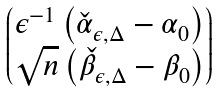<formula> <loc_0><loc_0><loc_500><loc_500>\begin{pmatrix} \epsilon ^ { - 1 } \left ( \check { \alpha } _ { \epsilon , \Delta } - \alpha _ { 0 } \right ) \\ \sqrt { n } \left ( \check { \beta } _ { \epsilon , \Delta } - \beta _ { 0 } \right ) \end{pmatrix}</formula> 